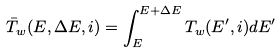<formula> <loc_0><loc_0><loc_500><loc_500>\bar { T } _ { w } ( E , \Delta E , i ) = \int _ { E } ^ { E + \Delta E } T _ { w } ( E ^ { \prime } , i ) d E ^ { \prime }</formula> 